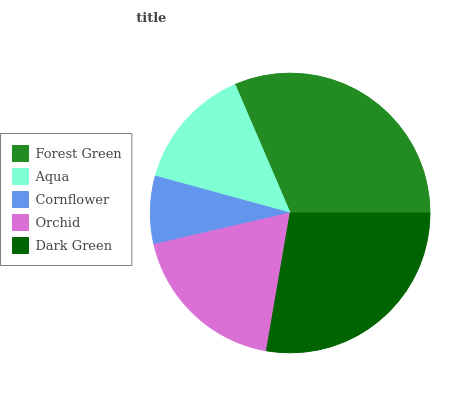Is Cornflower the minimum?
Answer yes or no. Yes. Is Forest Green the maximum?
Answer yes or no. Yes. Is Aqua the minimum?
Answer yes or no. No. Is Aqua the maximum?
Answer yes or no. No. Is Forest Green greater than Aqua?
Answer yes or no. Yes. Is Aqua less than Forest Green?
Answer yes or no. Yes. Is Aqua greater than Forest Green?
Answer yes or no. No. Is Forest Green less than Aqua?
Answer yes or no. No. Is Orchid the high median?
Answer yes or no. Yes. Is Orchid the low median?
Answer yes or no. Yes. Is Forest Green the high median?
Answer yes or no. No. Is Cornflower the low median?
Answer yes or no. No. 